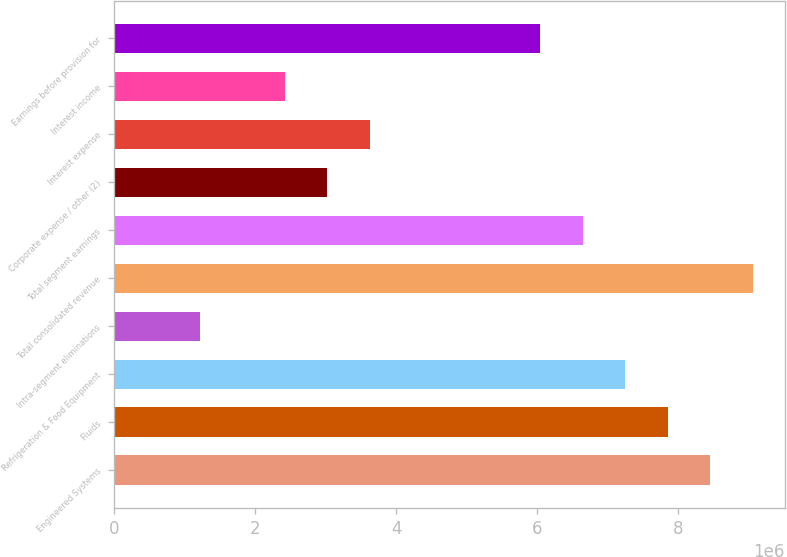Convert chart. <chart><loc_0><loc_0><loc_500><loc_500><bar_chart><fcel>Engineered Systems<fcel>Fluids<fcel>Refrigeration & Food Equipment<fcel>Intra-segment eliminations<fcel>Total consolidated revenue<fcel>Total segment earnings<fcel>Corporate expense / other (2)<fcel>Interest expense<fcel>Interest income<fcel>Earnings before provision for<nl><fcel>8.46051e+06<fcel>7.85619e+06<fcel>7.25187e+06<fcel>1.20865e+06<fcel>9.06483e+06<fcel>6.64755e+06<fcel>3.02162e+06<fcel>3.62594e+06<fcel>2.41729e+06<fcel>6.04322e+06<nl></chart> 